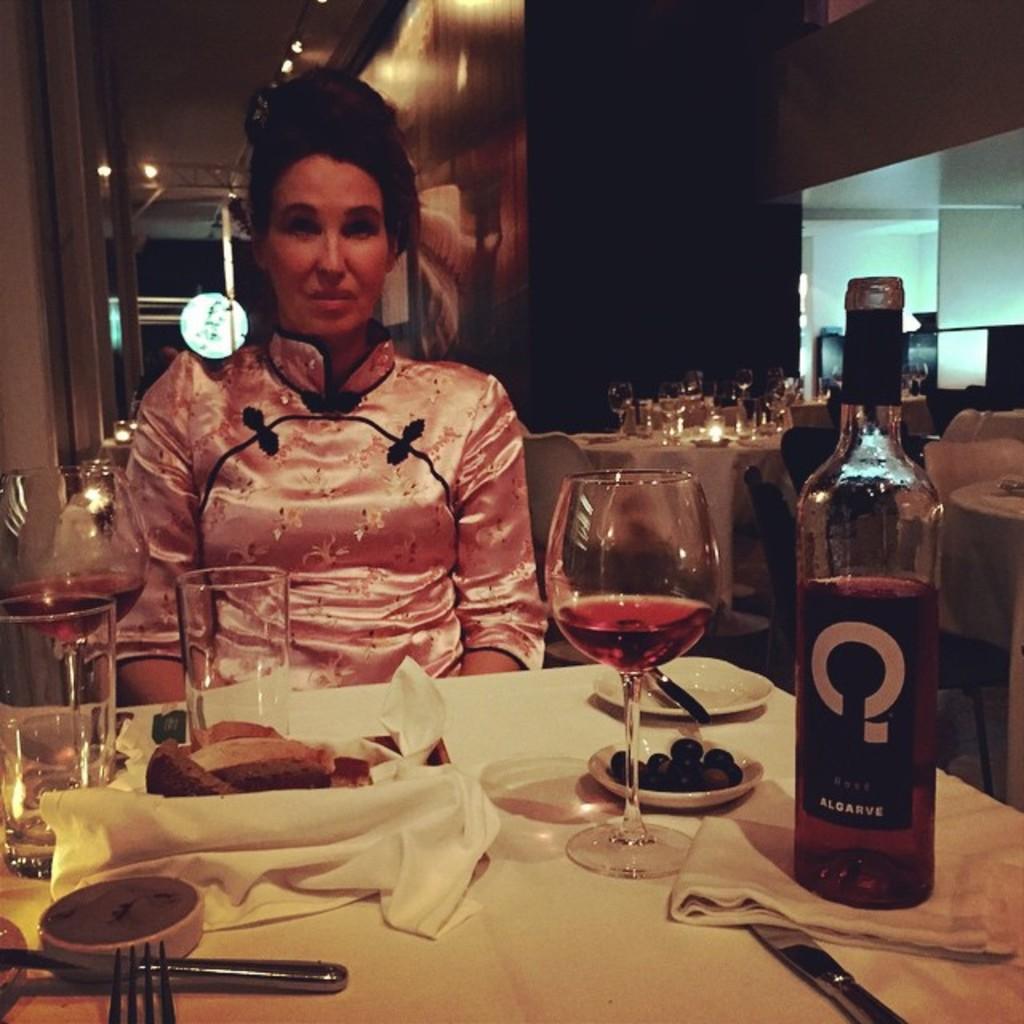In one or two sentences, can you explain what this image depicts? In this image i can see a woman in pink dress is sitting in front of a table. On the table i can see few glasses, a wine bottle, few spoons, few plates with food items in them and a cloth. In the background i can see the wall,few tables and objects in it and few lights. 